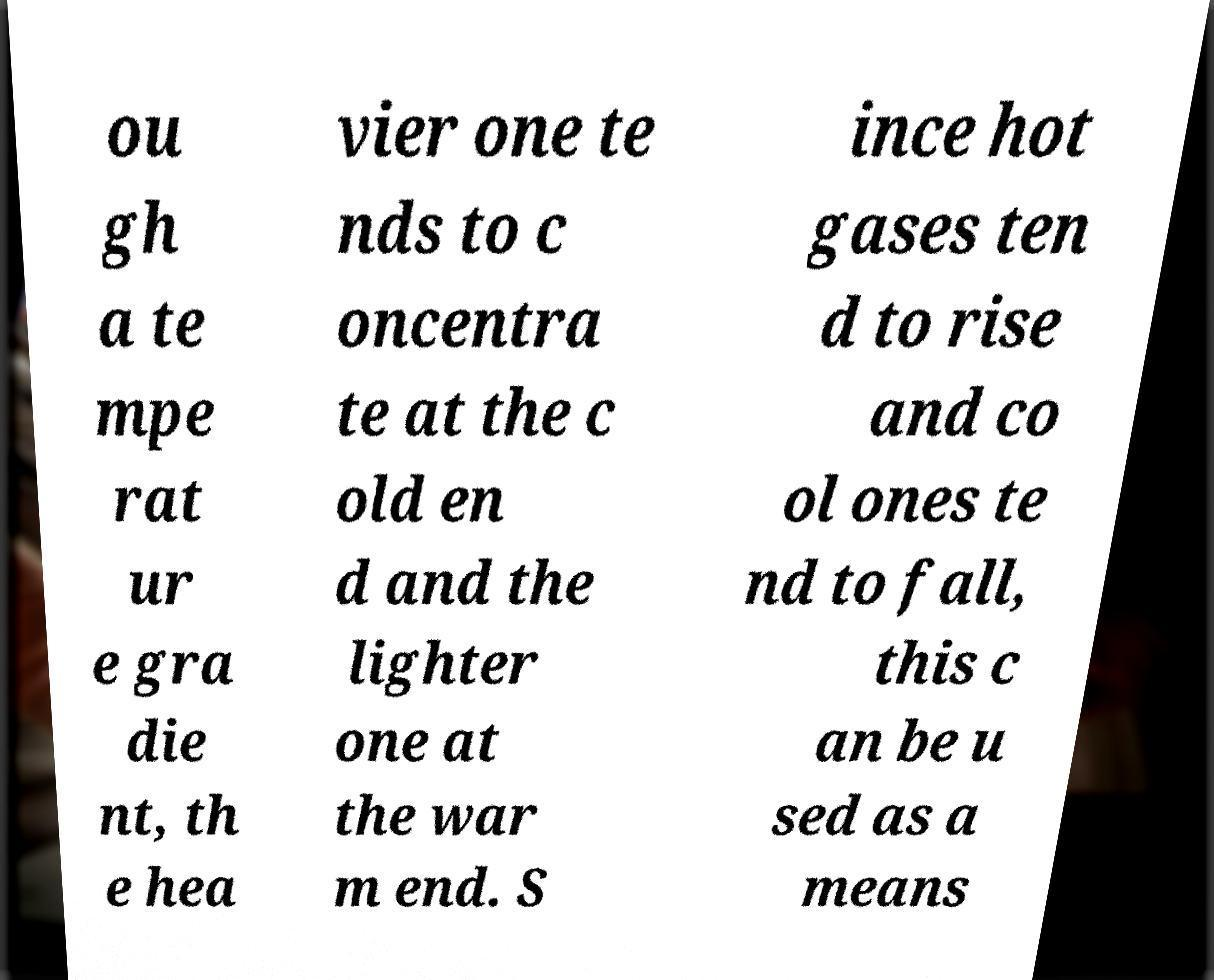Can you read and provide the text displayed in the image?This photo seems to have some interesting text. Can you extract and type it out for me? ou gh a te mpe rat ur e gra die nt, th e hea vier one te nds to c oncentra te at the c old en d and the lighter one at the war m end. S ince hot gases ten d to rise and co ol ones te nd to fall, this c an be u sed as a means 